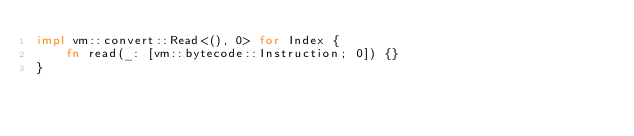Convert code to text. <code><loc_0><loc_0><loc_500><loc_500><_Rust_>impl vm::convert::Read<(), 0> for Index {
    fn read(_: [vm::bytecode::Instruction; 0]) {}
}
</code> 